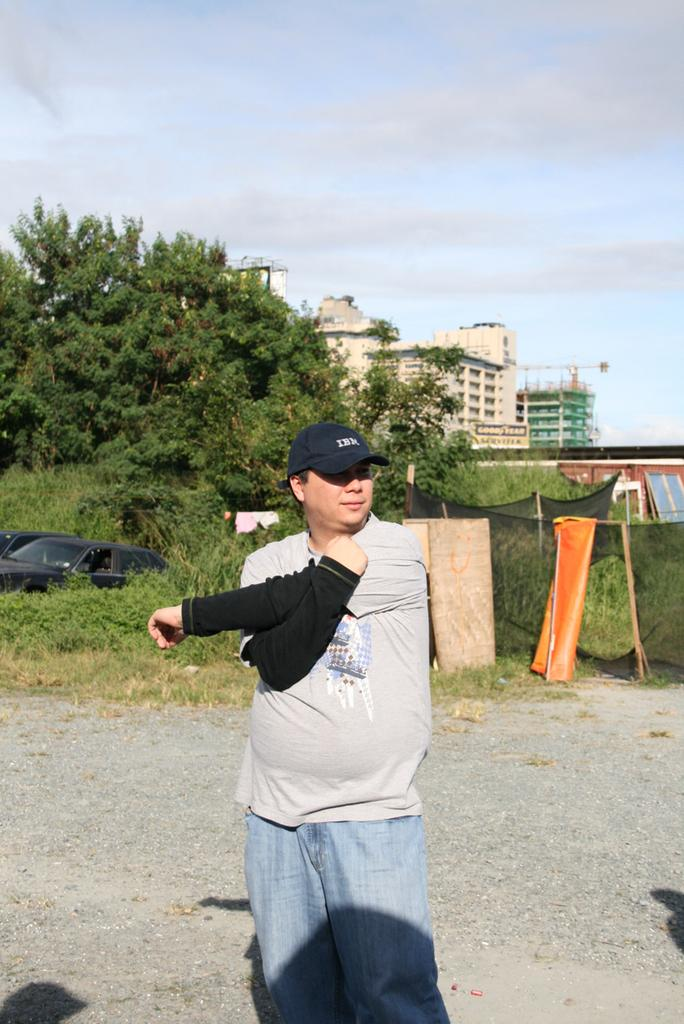What is the main subject of the image? There is a man in the image. What is the man wearing on his head? The man is wearing a cap. Where is the man standing? The man is standing on the ground. What is the man doing in the image? The man is looking somewhere. What can be seen in the background of the image? There is a car, trees, and buildings in the background of the image. What type of lettuce is growing in the middle of the image? There is no lettuce present in the image; it features a man standing on the ground and looking somewhere, with a background that includes a car, trees, and buildings. 